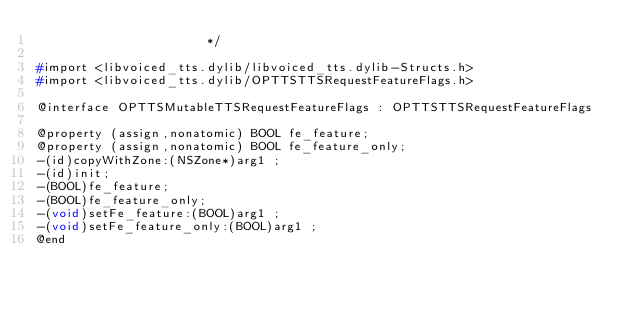<code> <loc_0><loc_0><loc_500><loc_500><_C_>                       */

#import <libvoiced_tts.dylib/libvoiced_tts.dylib-Structs.h>
#import <libvoiced_tts.dylib/OPTTSTTSRequestFeatureFlags.h>

@interface OPTTSMutableTTSRequestFeatureFlags : OPTTSTTSRequestFeatureFlags

@property (assign,nonatomic) BOOL fe_feature; 
@property (assign,nonatomic) BOOL fe_feature_only; 
-(id)copyWithZone:(NSZone*)arg1 ;
-(id)init;
-(BOOL)fe_feature;
-(BOOL)fe_feature_only;
-(void)setFe_feature:(BOOL)arg1 ;
-(void)setFe_feature_only:(BOOL)arg1 ;
@end

</code> 